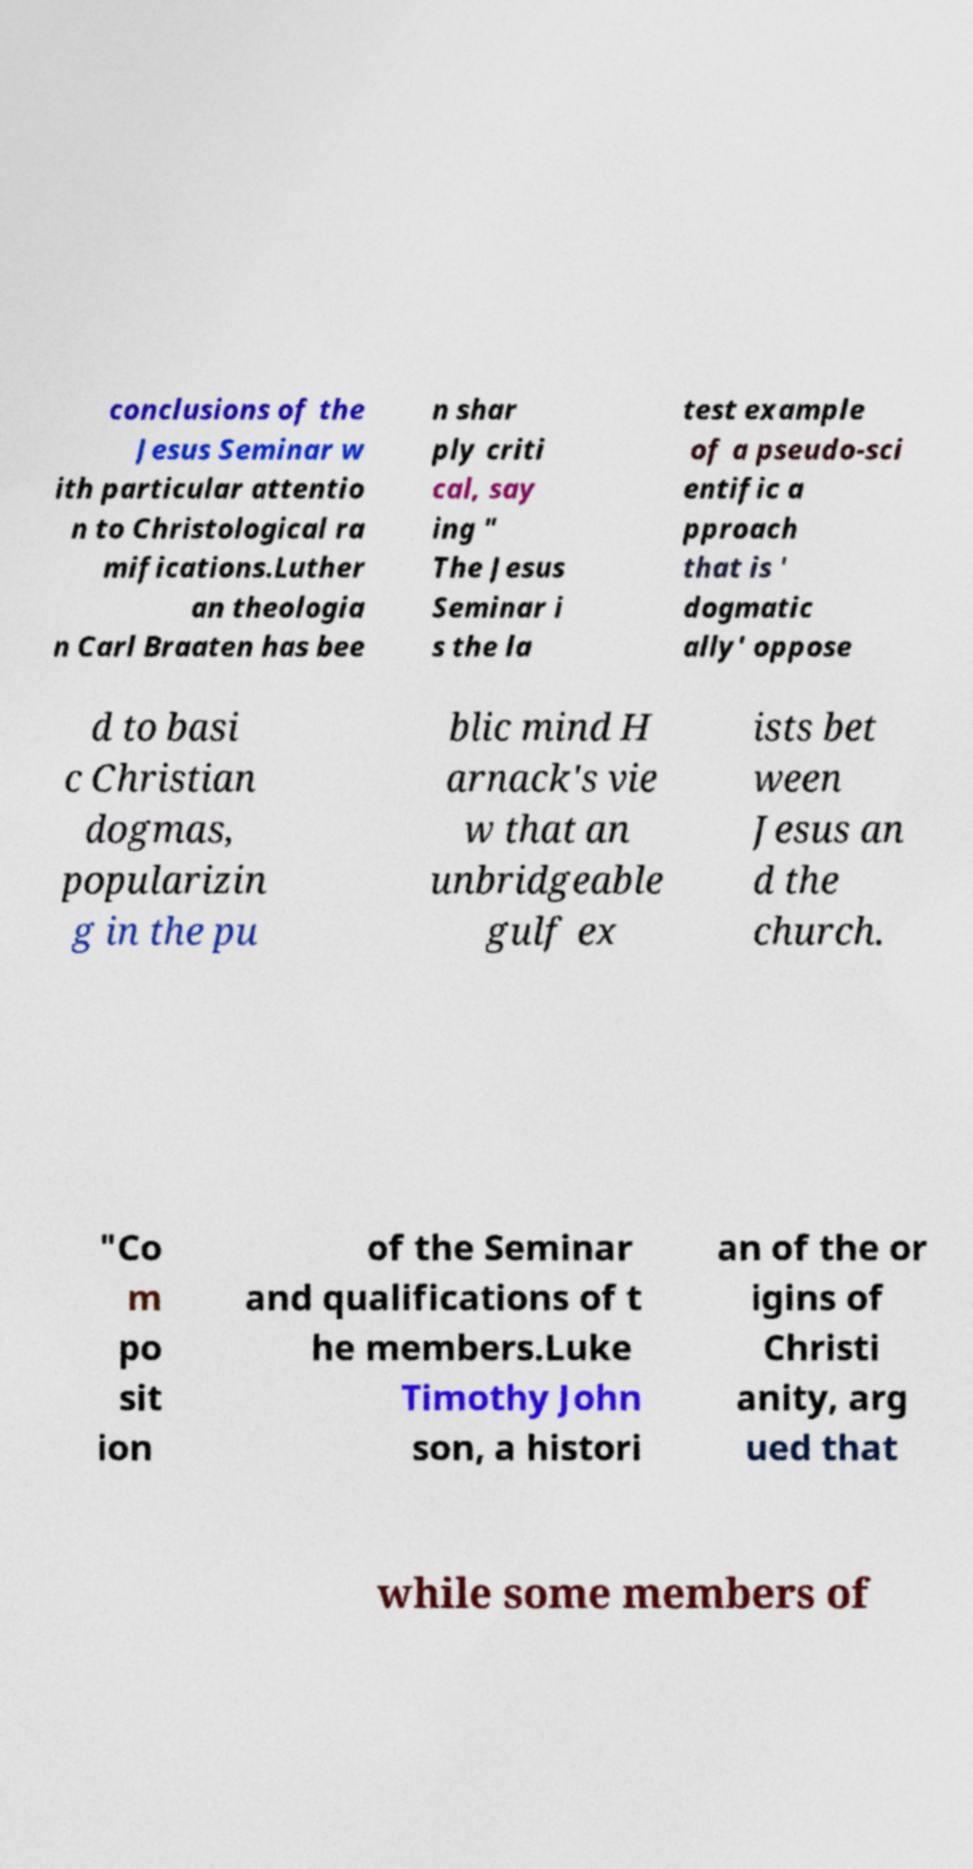Can you accurately transcribe the text from the provided image for me? conclusions of the Jesus Seminar w ith particular attentio n to Christological ra mifications.Luther an theologia n Carl Braaten has bee n shar ply criti cal, say ing " The Jesus Seminar i s the la test example of a pseudo-sci entific a pproach that is ' dogmatic ally' oppose d to basi c Christian dogmas, popularizin g in the pu blic mind H arnack's vie w that an unbridgeable gulf ex ists bet ween Jesus an d the church. "Co m po sit ion of the Seminar and qualifications of t he members.Luke Timothy John son, a histori an of the or igins of Christi anity, arg ued that while some members of 